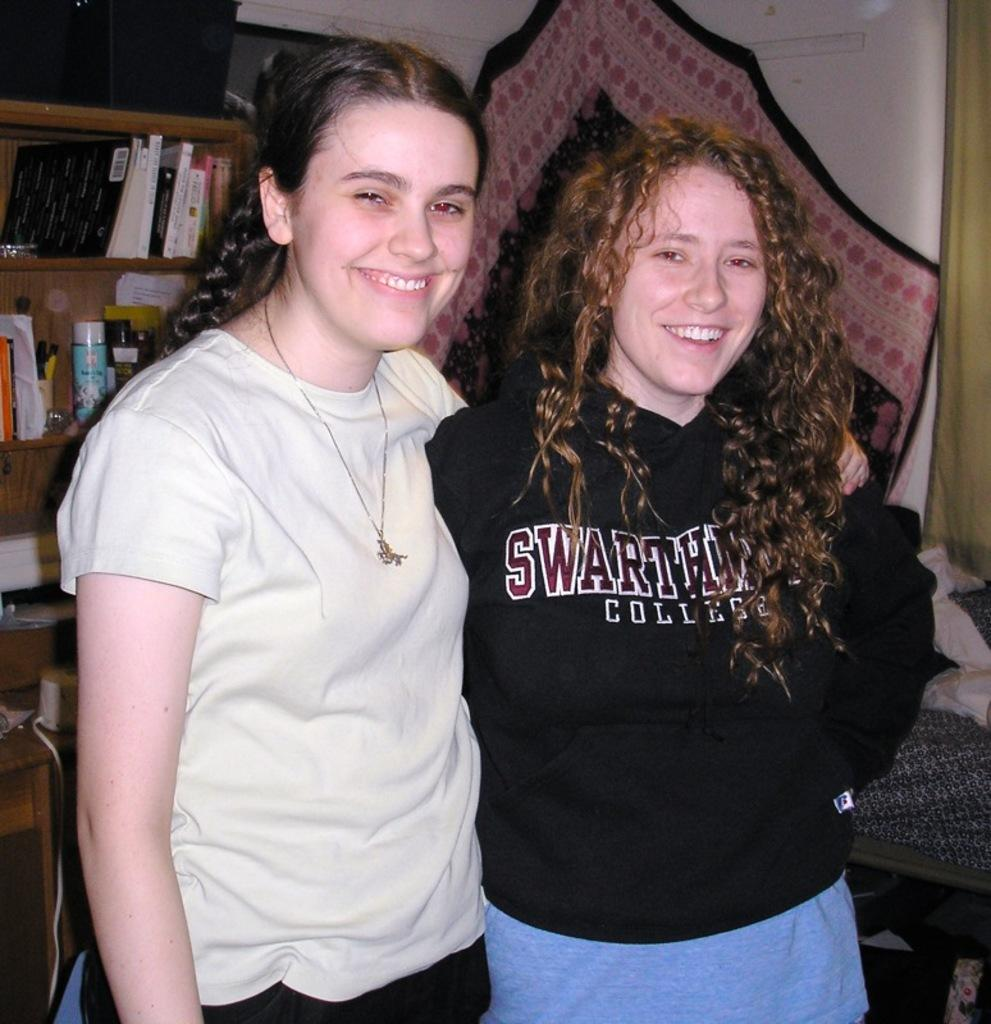How many women are in the image? There are two women in the image. What are the women doing in the image? The women are standing and smiling. What can be seen in the background of the image? In the background, there are clothes, books, objects in racks, a wall, a device, and other objects. What type of dinosaurs can be seen in the image? There are no dinosaurs present in the image. What color is the volleyball in the image? There is no volleyball present in the image. 